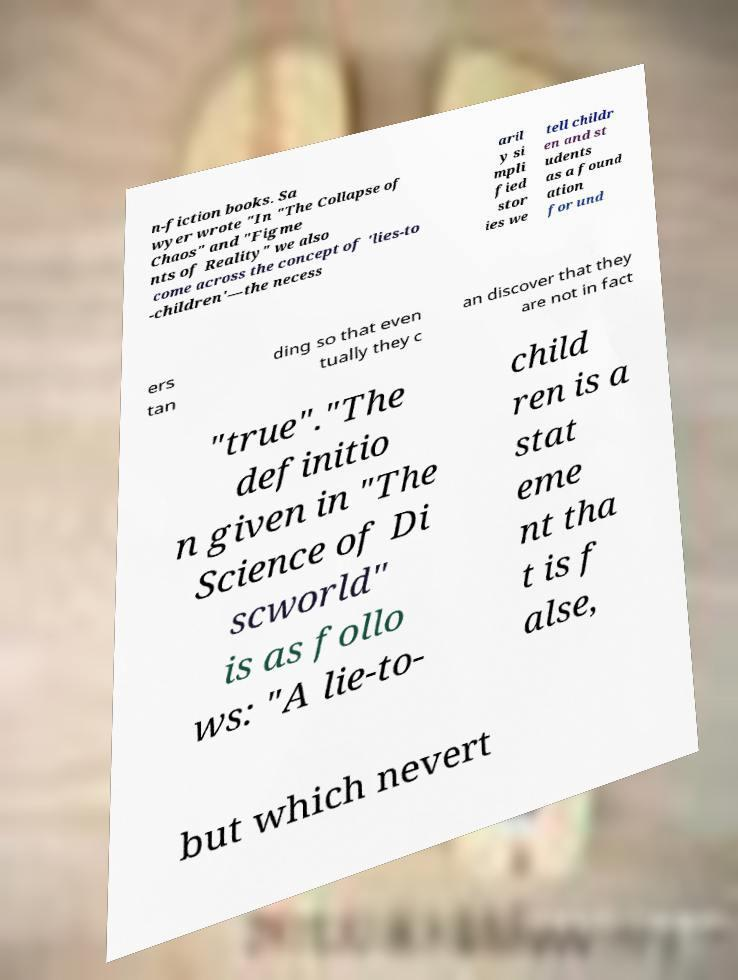I need the written content from this picture converted into text. Can you do that? n-fiction books. Sa wyer wrote "In "The Collapse of Chaos" and "Figme nts of Reality" we also come across the concept of 'lies-to -children'—the necess aril y si mpli fied stor ies we tell childr en and st udents as a found ation for und ers tan ding so that even tually they c an discover that they are not in fact "true"."The definitio n given in "The Science of Di scworld" is as follo ws: "A lie-to- child ren is a stat eme nt tha t is f alse, but which nevert 